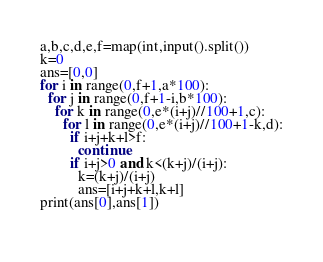<code> <loc_0><loc_0><loc_500><loc_500><_Python_>a,b,c,d,e,f=map(int,input().split())
k=0
ans=[0,0]
for i in range(0,f+1,a*100):
  for j in range(0,f+1-i,b*100):
    for k in range(0,e*(i+j)//100+1,c):
      for l in range(0,e*(i+j)//100+1-k,d):
        if i+j+k+l>f:
          continue
        if i+j>0 and k<(k+j)/(i+j):
          k=(k+j)/(i+j)
          ans=[i+j+k+l,k+l]
print(ans[0],ans[1])
        </code> 